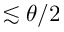<formula> <loc_0><loc_0><loc_500><loc_500>\lesssim \theta / 2</formula> 